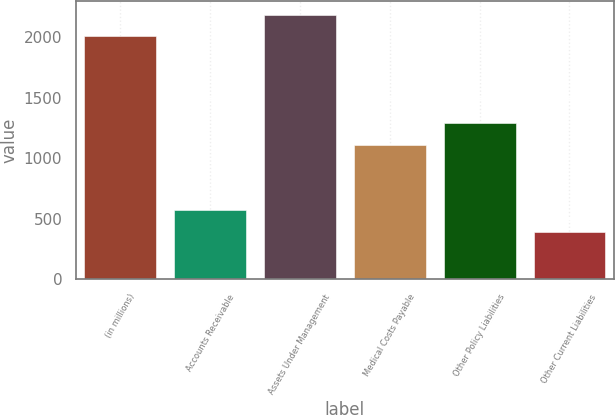Convert chart. <chart><loc_0><loc_0><loc_500><loc_500><bar_chart><fcel>(in millions)<fcel>Accounts Receivable<fcel>Assets Under Management<fcel>Medical Costs Payable<fcel>Other Policy Liabilities<fcel>Other Current Liabilities<nl><fcel>2007<fcel>572.2<fcel>2185.2<fcel>1109<fcel>1287.2<fcel>394<nl></chart> 